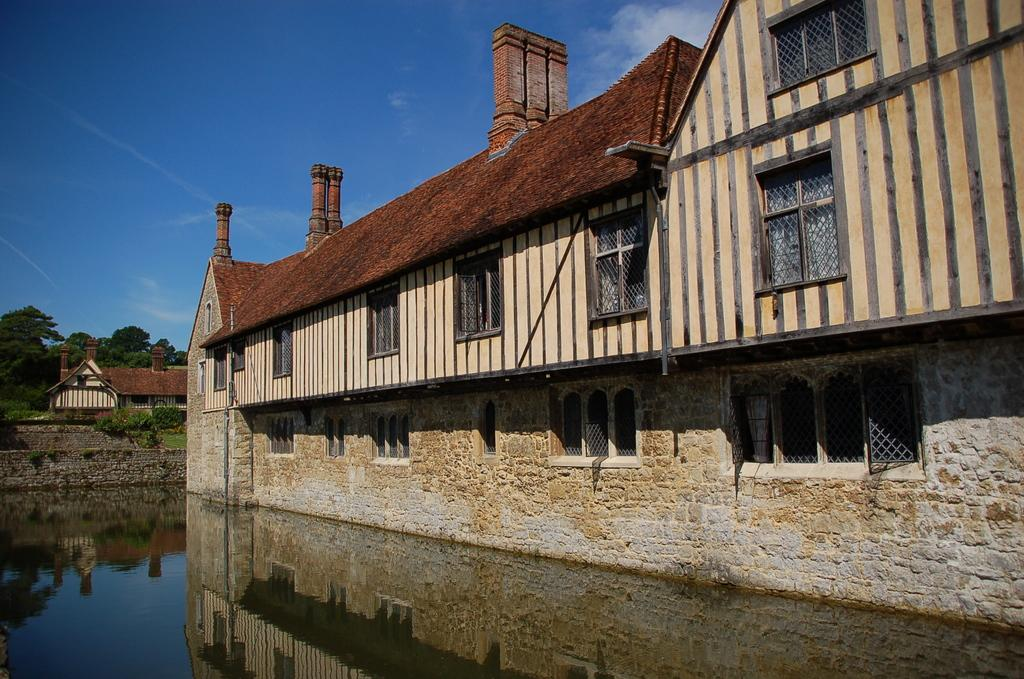What is the primary element visible in the image? There is water in the image. What type of structures can be seen in the image? There are stone houses in the image. What type of vegetation is present in the image? Shrubs and trees are visible in the image. What type of barrier is present in the image? There is a stone wall in the image. What is the color of the sky in the background? The sky is blue in the background. What can be seen in the sky? Clouds are present in the sky. How many nets are visible in the image? There are no nets present in the image. What type of activity are the stone houses engaged in? Stone houses are inanimate objects and cannot engage in activities. 